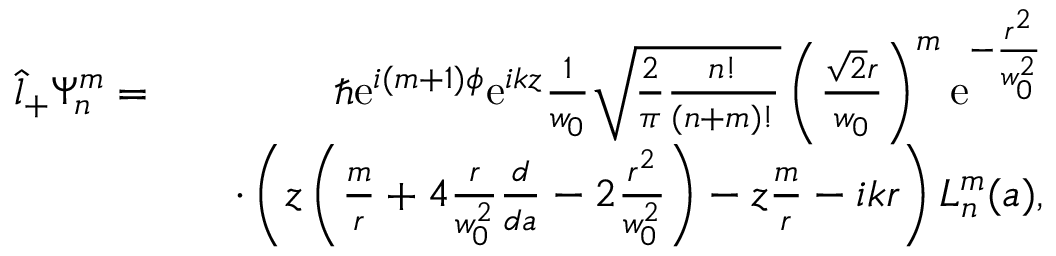Convert formula to latex. <formula><loc_0><loc_0><loc_500><loc_500>\begin{array} { r l r } { \hat { l } _ { + } \Psi _ { n } ^ { m } = } & { \hbar { e } ^ { i ( m + 1 ) \phi } e ^ { i k z } \frac { 1 } { w _ { 0 } } \sqrt { \frac { 2 } { \pi } \frac { n ! } { ( n + m ) ! } } \left ( \frac { \sqrt { 2 } r } { w _ { 0 } } \right ) ^ { m } e ^ { - \frac { r ^ { 2 } } { w _ { 0 } ^ { 2 } } } } \\ & { \cdot \left ( z \left ( \frac { m } { r } + 4 \frac { r } { w _ { 0 } ^ { 2 } } \frac { d } { d a } - 2 \frac { r ^ { 2 } } { w _ { 0 } ^ { 2 } } \right ) - z \frac { m } { r } - i k r \right ) L _ { n } ^ { m } ( a ) , } \end{array}</formula> 